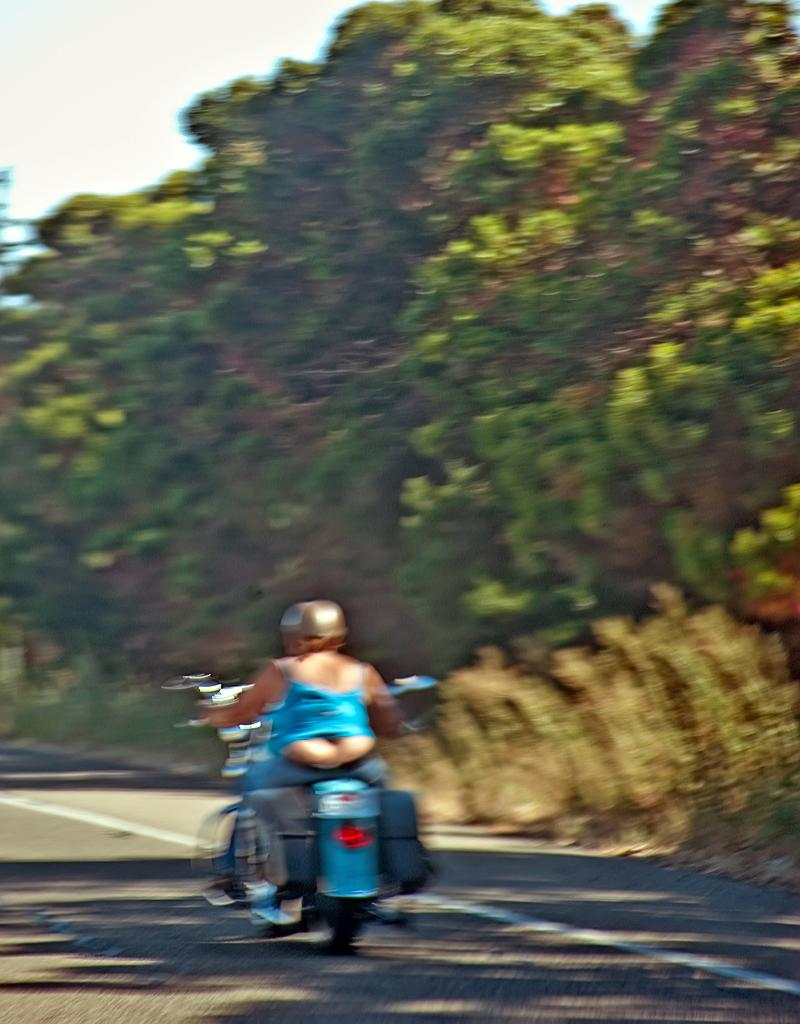What is the main subject of the image? There is a person riding a motorcycle in the image. Where is the person riding the motorcycle? The person is on the road. What can be seen on the right side of the image? There are trees on the right side of the image. What is visible in the background of the image? The sky is visible in the background of the image. How many balloons are tied to the motorcycle in the image? There are no balloons present in the image; it only features a person riding a motorcycle on the road. 